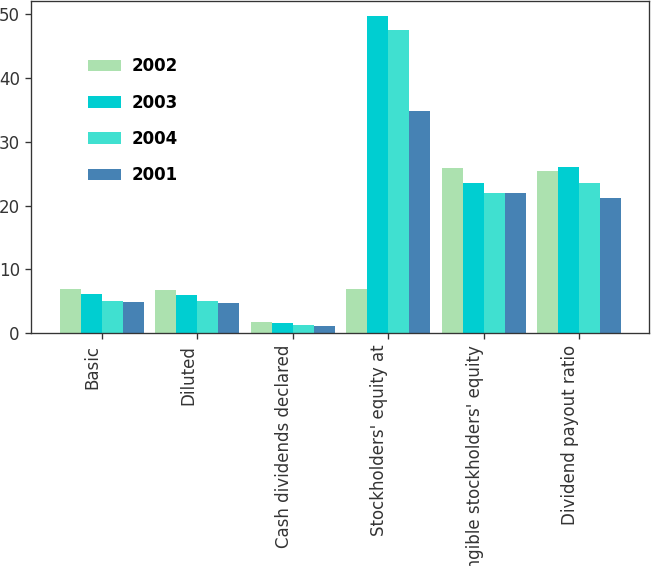Convert chart. <chart><loc_0><loc_0><loc_500><loc_500><stacked_bar_chart><ecel><fcel>Basic<fcel>Diluted<fcel>Cash dividends declared<fcel>Stockholders' equity at<fcel>Tangible stockholders' equity<fcel>Dividend payout ratio<nl><fcel>2002<fcel>6.88<fcel>6.73<fcel>1.75<fcel>6.88<fcel>25.91<fcel>25.42<nl><fcel>2003<fcel>6.14<fcel>6<fcel>1.6<fcel>49.68<fcel>23.62<fcel>26<nl><fcel>2004<fcel>5.08<fcel>4.95<fcel>1.2<fcel>47.55<fcel>21.97<fcel>23.62<nl><fcel>2001<fcel>4.94<fcel>4.78<fcel>1.05<fcel>34.82<fcel>22.04<fcel>21.24<nl></chart> 